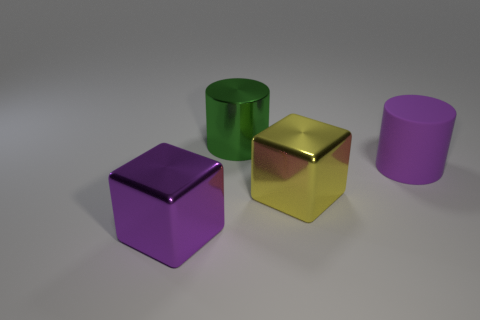Are there an equal number of green cylinders in front of the rubber object and blocks that are to the left of the large green metallic object?
Provide a short and direct response. No. What number of tiny cyan cubes are the same material as the large purple block?
Provide a short and direct response. 0. What shape is the other thing that is the same color as the large matte object?
Your answer should be compact. Cube. There is a big purple object left of the matte object; is its shape the same as the purple thing to the right of the green cylinder?
Offer a terse response. No. Are there the same number of green metallic things on the left side of the yellow object and small green metal spheres?
Provide a short and direct response. No. What is the color of the other large thing that is the same shape as the large yellow thing?
Your answer should be compact. Purple. Do the big cylinder that is right of the big green metallic cylinder and the large yellow block have the same material?
Make the answer very short. No. What number of small objects are blue rubber things or green cylinders?
Offer a very short reply. 0. Do the yellow object and the purple object to the right of the yellow block have the same size?
Your answer should be very brief. Yes. What number of cyan things are matte objects or big cylinders?
Ensure brevity in your answer.  0. 